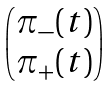<formula> <loc_0><loc_0><loc_500><loc_500>\begin{pmatrix} \pi _ { - } ( t ) \\ \pi _ { + } ( t ) \end{pmatrix}</formula> 